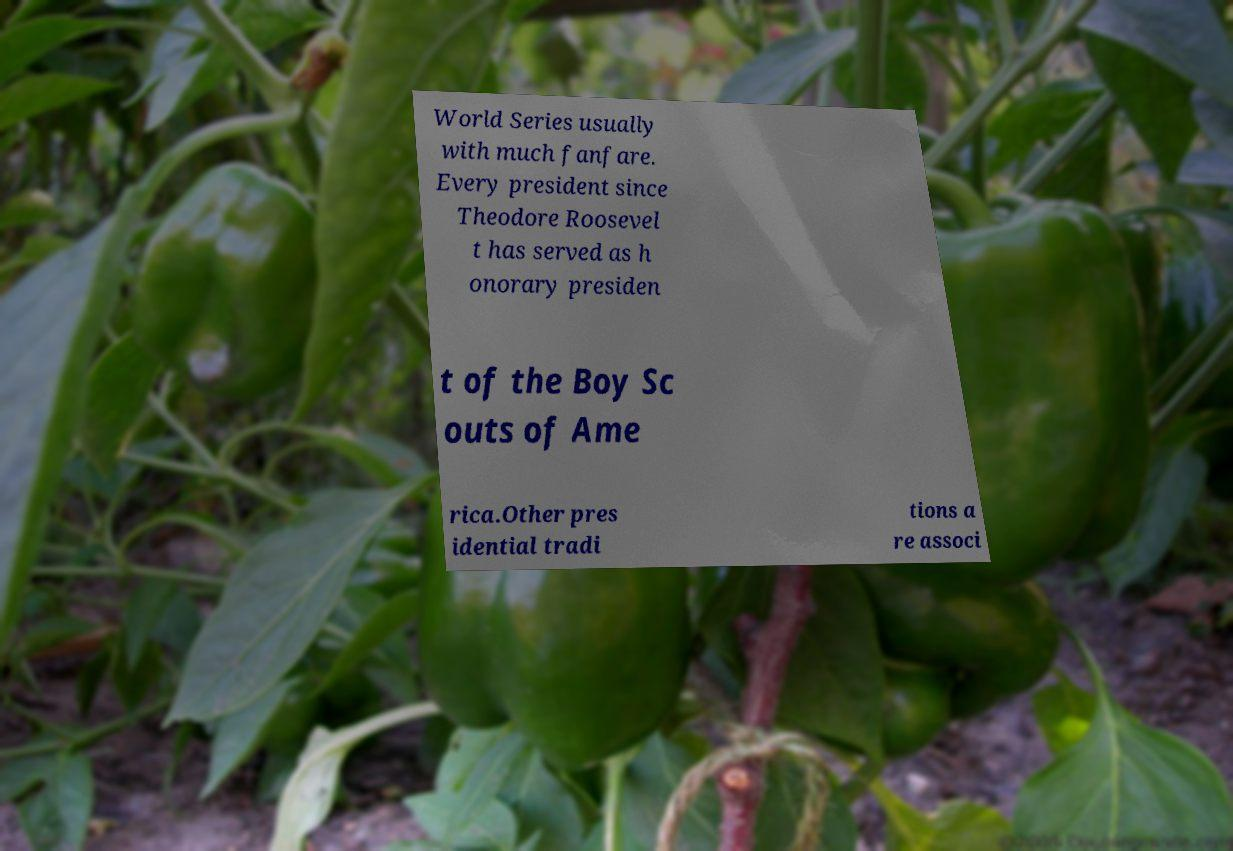Could you extract and type out the text from this image? World Series usually with much fanfare. Every president since Theodore Roosevel t has served as h onorary presiden t of the Boy Sc outs of Ame rica.Other pres idential tradi tions a re associ 